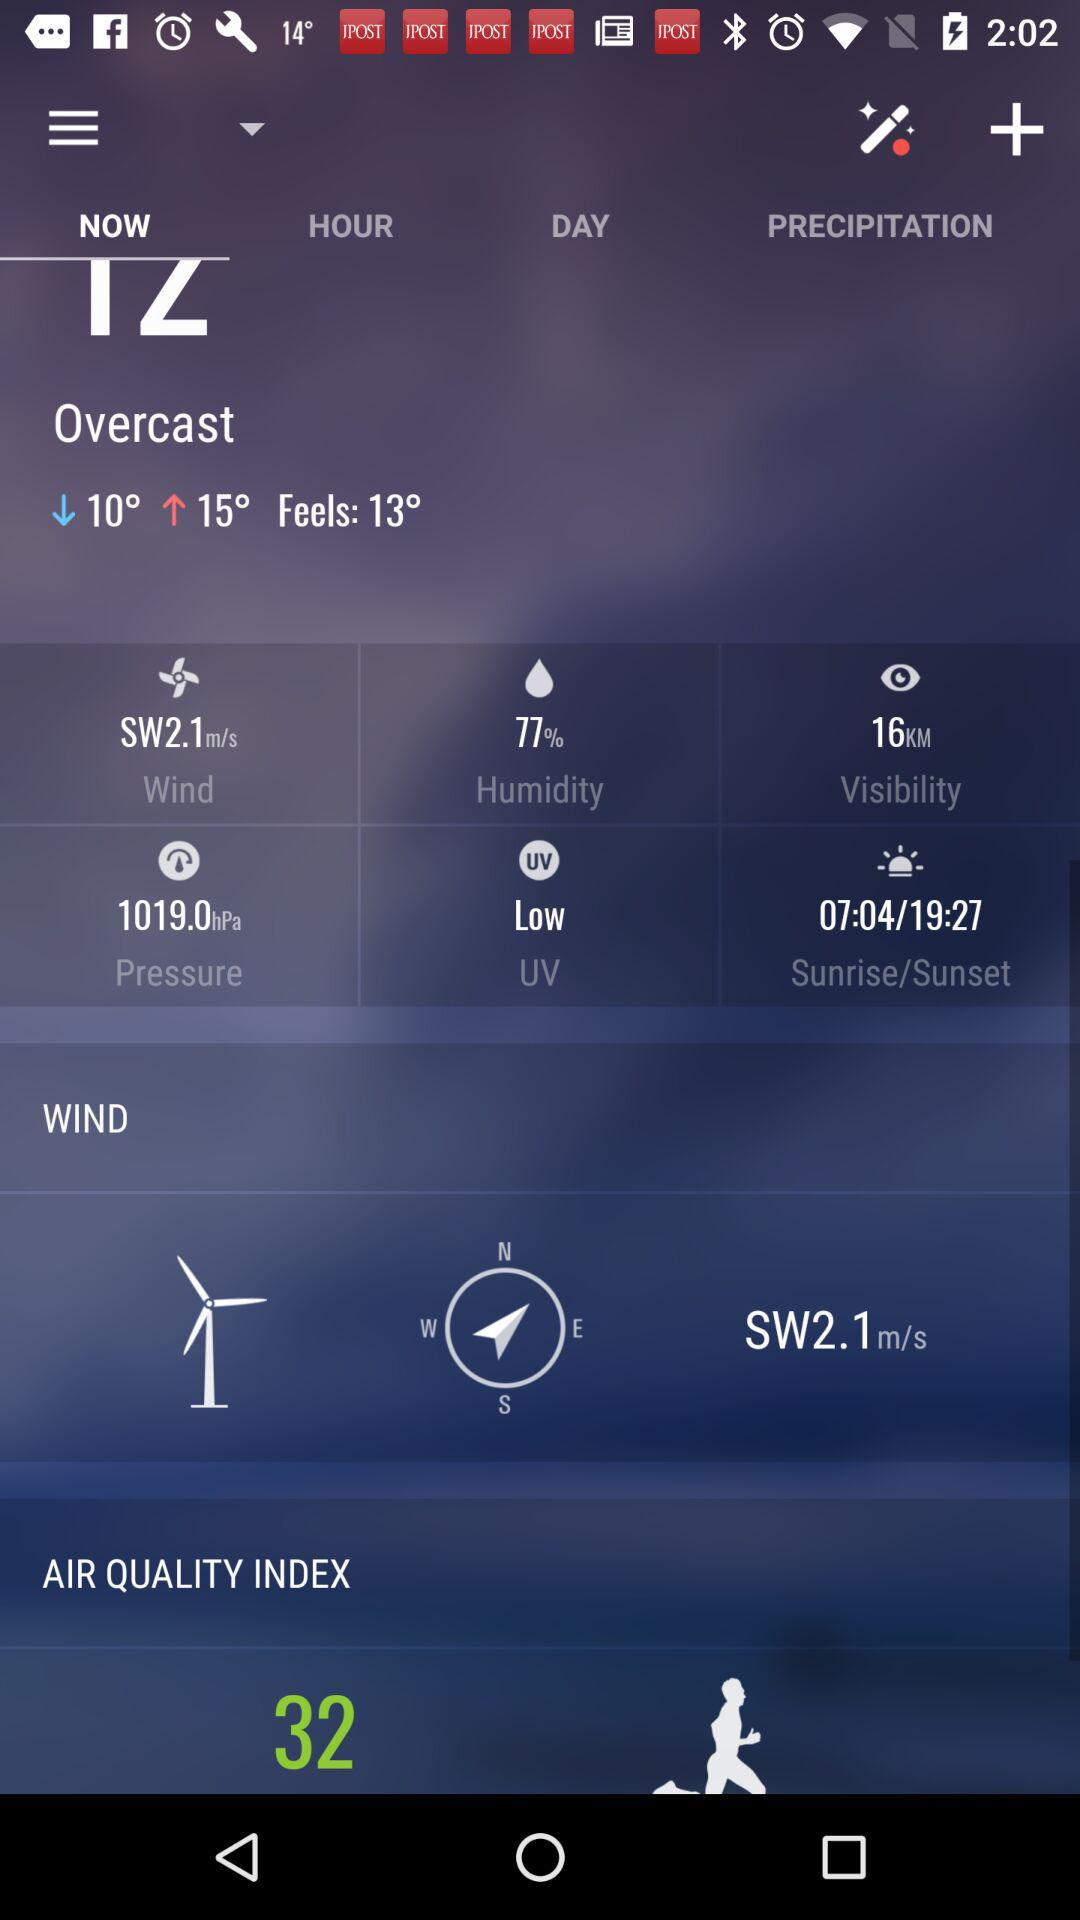What is the air quality index?
Answer the question using a single word or phrase. 32 